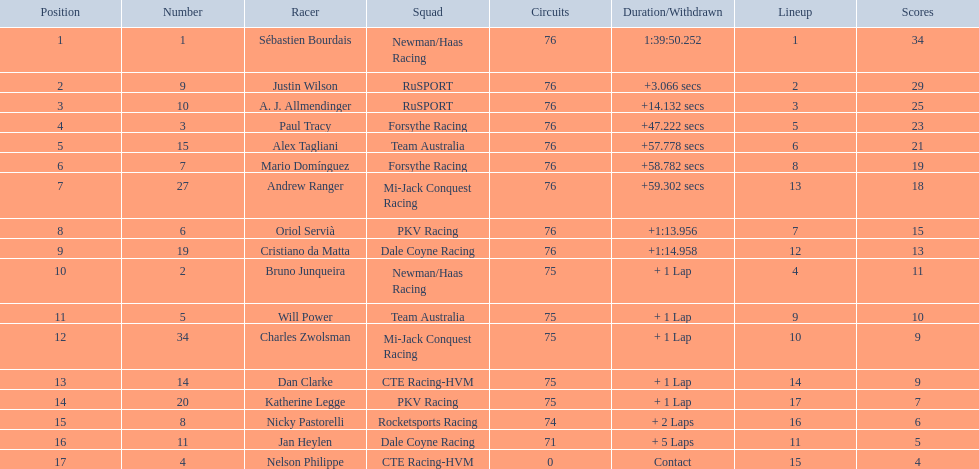Which drivers completed all 76 laps? Sébastien Bourdais, Justin Wilson, A. J. Allmendinger, Paul Tracy, Alex Tagliani, Mario Domínguez, Andrew Ranger, Oriol Servià, Cristiano da Matta. Of these drivers, which ones finished less than a minute behind first place? Paul Tracy, Alex Tagliani, Mario Domínguez, Andrew Ranger. Of these drivers, which ones finished with a time less than 50 seconds behind first place? Justin Wilson, A. J. Allmendinger, Paul Tracy. Of these three drivers, who finished last? Paul Tracy. 